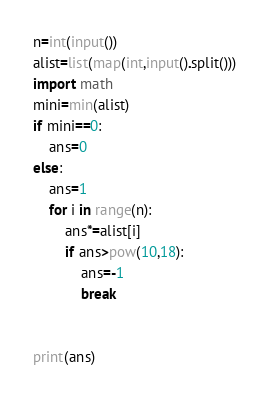Convert code to text. <code><loc_0><loc_0><loc_500><loc_500><_Python_>n=int(input())
alist=list(map(int,input().split()))
import math
mini=min(alist)
if mini==0:
    ans=0
else:
    ans=1
    for i in range(n):
        ans*=alist[i]
        if ans>pow(10,18):
            ans=-1
            break


print(ans)</code> 